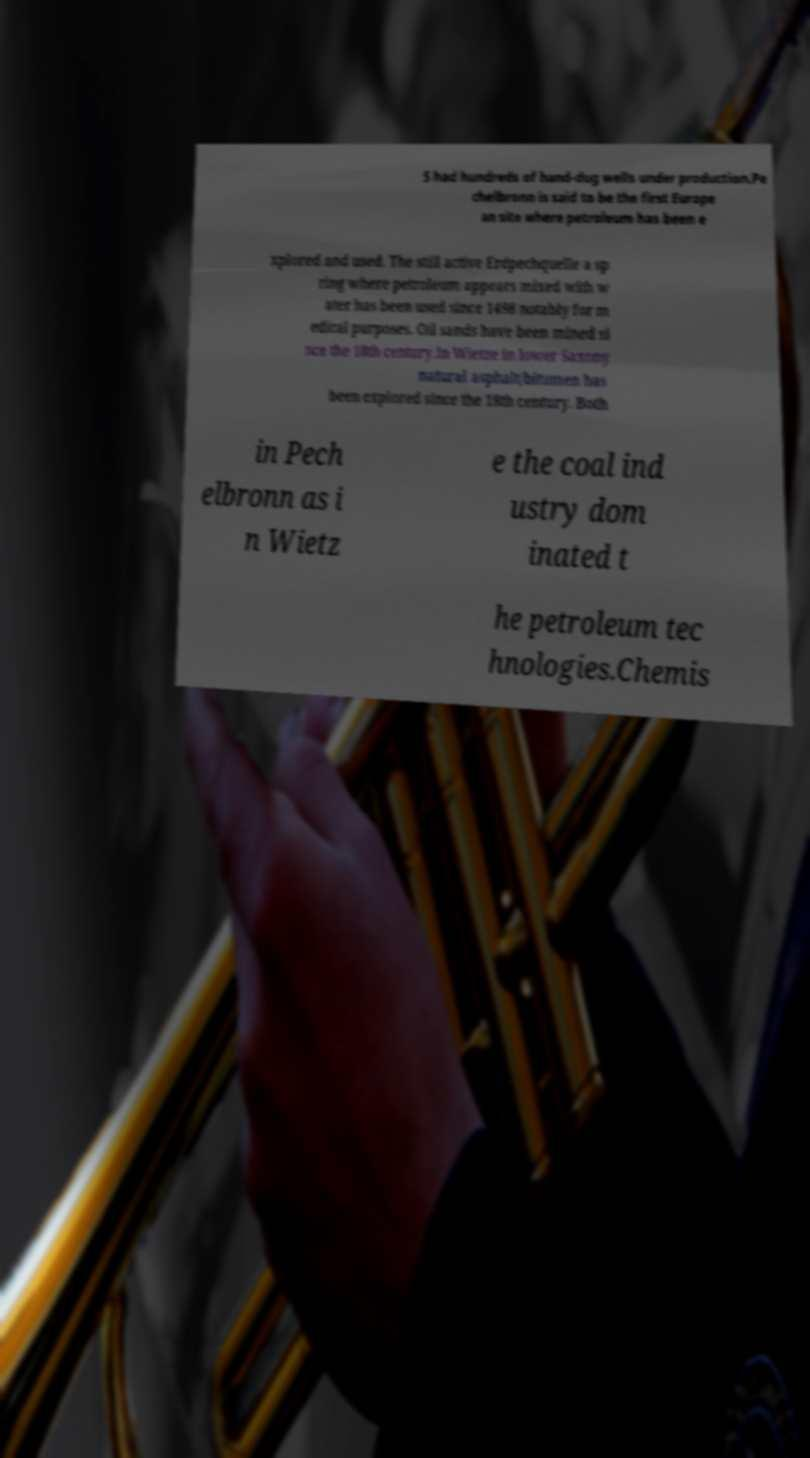What messages or text are displayed in this image? I need them in a readable, typed format. 5 had hundreds of hand-dug wells under production.Pe chelbronn is said to be the first Europe an site where petroleum has been e xplored and used. The still active Erdpechquelle a sp ring where petroleum appears mixed with w ater has been used since 1498 notably for m edical purposes. Oil sands have been mined si nce the 18th century.In Wietze in lower Saxony natural asphalt/bitumen has been explored since the 18th century. Both in Pech elbronn as i n Wietz e the coal ind ustry dom inated t he petroleum tec hnologies.Chemis 